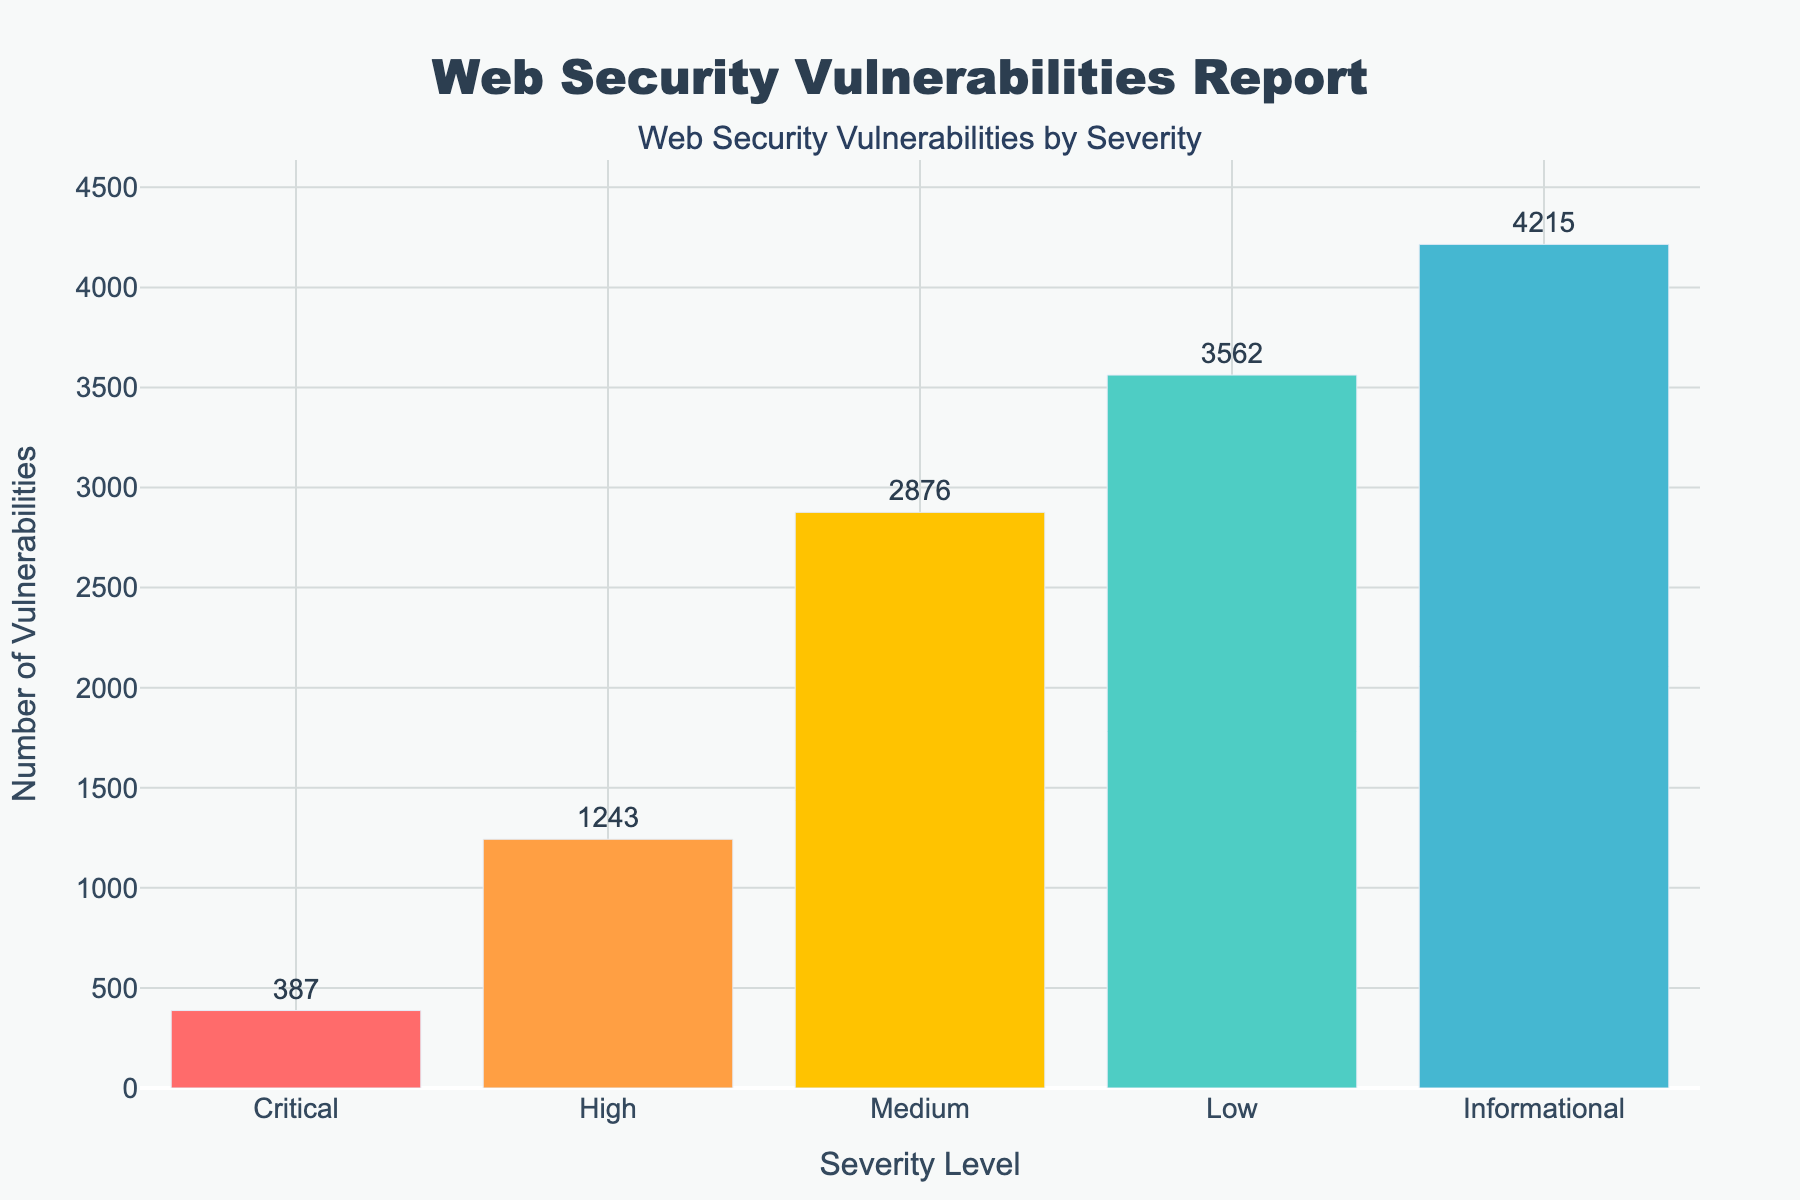Which severity level has the highest number of vulnerabilities? The bar for "Informational" is the tallest, indicating it has the highest number of vulnerabilities.
Answer: Informational Among the "High" and "Critical" severity levels, which one has more vulnerabilities? The bar for "High" is taller than the bar for "Critical," indicating that "High" has more vulnerabilities.
Answer: High What is the total number of vulnerabilities reported for "Medium" and "Low" severity levels combined? The "Medium" severity level has 2876 vulnerabilities and the "Low" severity level has 3562 vulnerabilities. Adding these together gives 2876 + 3562 = 6438.
Answer: 6438 Which is the second lowest in terms of the number of vulnerabilities, and how many does it have? The "Critical" bar is the second lowest, with 387 vulnerabilities. The lowest is "Informational," but the next one higher is "Critical."
Answer: Critical, 387 How many more vulnerabilities does the "Informational" severity level have than the "High" severity level? The "Informational" severity level has 4215 vulnerabilities, and "High" has 1243 vulnerabilities. The difference is 4215 - 1243 = 2972.
Answer: 2972 What is the average number of vulnerabilities for "Critical", "High", and "Medium" severity levels combined? The total number of vulnerabilities for "Critical," "High," and "Medium" are 387 + 1243 + 2876 = 4506. The average is 4506 / 3 = 1502.
Answer: 1502 Which severity level is represented by the color green in the figure? The "Low" severity level is represented by the green color in the figure.
Answer: Low Which severity level has vulnerabilities more than twice that of the "Critical" level but less than that of the "Medium" level? "High" severity level has 1243 vulnerabilities, which is more than twice the "Critical" (387 * 2 = 774), but less than the "Medium" severity level (2876).
Answer: High 